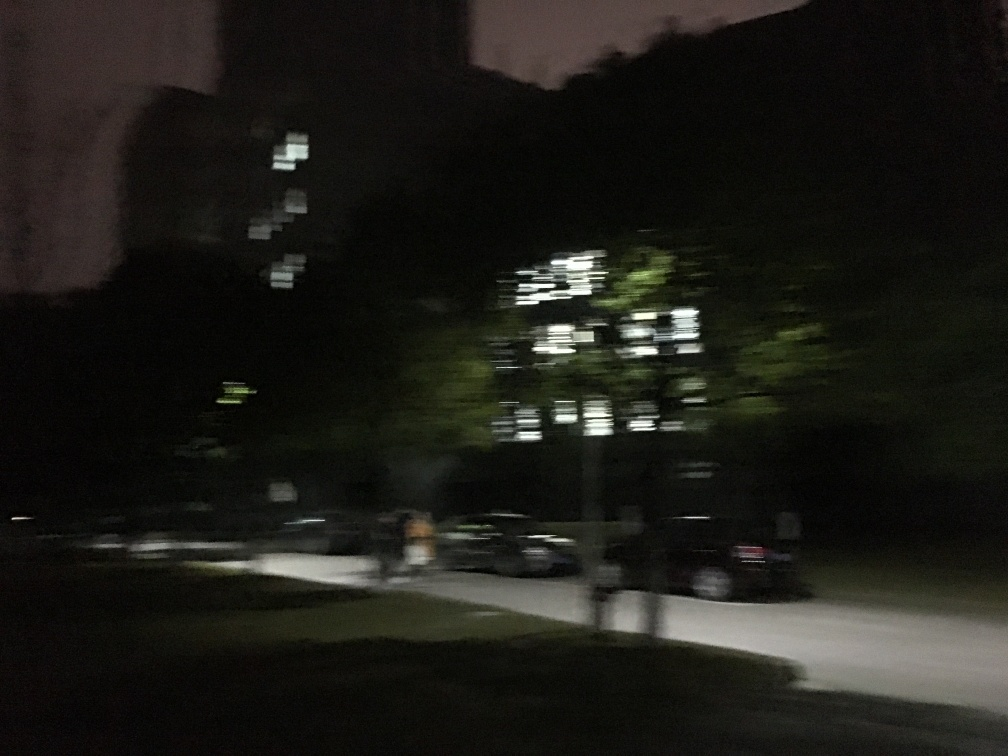Can you describe the setting and atmosphere in this image? The image appears to have been taken at nighttime, capturing a scene with limited lighting which contributes to the atmosphere of quiet and stillness. Sparse illumination from the building's windows offers minimal brightness, and suggests that the area is largely uninhabited at this hour. The blurred silhouette of a figure and a bicycle introduces a sense of movement, hinting at transient activity within an otherwise static environment. 